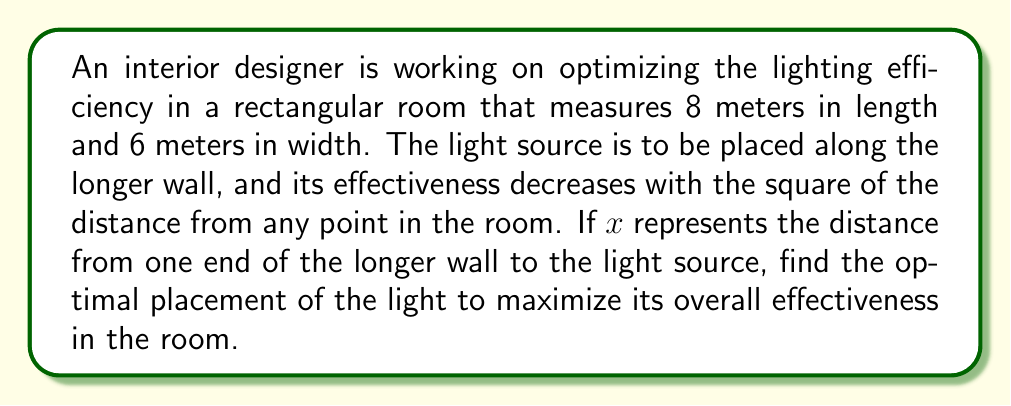Help me with this question. Let's approach this step-by-step:

1) First, we need to set up a function that represents the total effectiveness of the light in the room. We can do this by integrating the effectiveness over the entire area of the room.

2) The effectiveness at any point $(x,y)$ in the room can be represented as:

   $E(x,y) = \frac{1}{(x-a)^2 + y^2}$

   where $a$ is the position of the light source along the longer wall.

3) The total effectiveness will be the double integral of this function over the room:

   $T(a) = \int_0^6 \int_0^8 \frac{1}{(x-a)^2 + y^2} dx dy$

4) To find the maximum, we need to differentiate $T(a)$ with respect to $a$ and set it to zero. However, this integral is quite complex to evaluate directly.

5) We can simplify our problem by considering symmetry. The most effective position will likely be in the middle of the longer wall due to the room's rectangular shape.

6) So, we can set up our function with $a = 4$ (half of 8 meters) and check if this indeed gives us a maximum.

7) Let's calculate $\frac{dT}{da}$ at $a = 4$:

   $$\frac{dT}{da}\bigg|_{a=4} = \int_0^6 \int_0^8 \frac{-2(x-4)}{((x-4)^2 + y^2)^2} dx dy$$

8) Due to the symmetry of the room when $a = 4$, for every point $(x,y)$ that contributes a positive value to this integral, there's a corresponding point $(8-x,y)$ that contributes an equal negative value.

9) Therefore, the entire integral evaluates to zero when $a = 4$, confirming that this is indeed a critical point.

10) To verify it's a maximum, we could check the second derivative, but the symmetry of the situation already suggests this is a global maximum.

Thus, the optimal placement for the light source is at the midpoint of the longer wall.
Answer: 4 meters from either end of the longer wall 